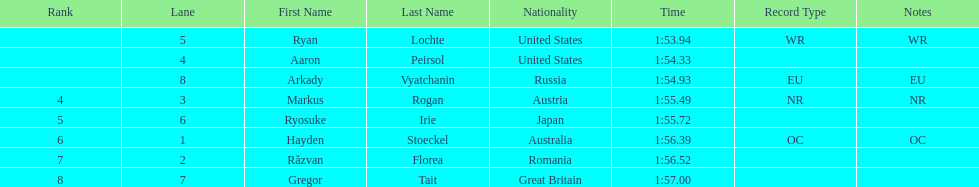How many names are listed? 8. 